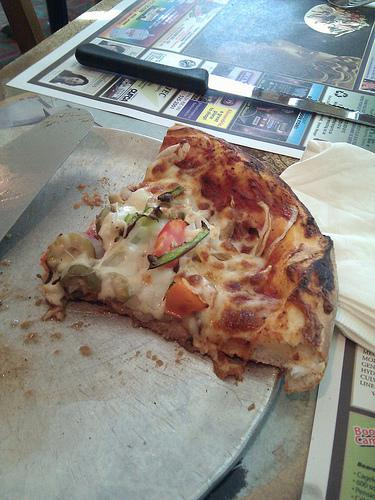Describe the table setting where the pizza is being served. The table setting includes a placemat full of ads, a newspaper, white napkins, a black-handled knife, a metal pizza server, and a round silver pan holding the pizza. List three emotions you may associate with this image. Happiness, satisfaction, and craving. Count the number of visible utensils in the image and describe their functions. There are 3 utensils: a knife for cutting, a metal pizza server for serving, and a silver spatula for handling the pizza slice. Identify the primary object in the image and describe its appearance. A thick crust pizza topped with melted cheese and various toppings, served on a round metal pan. Can you see any print material in the image? If so, describe its location and appearance. There is a newspaper placemat on the table beneath the pizza, which is full of ads. What is the primary interaction between the objects in the image? The primary interaction is between the pizza, its toppings, and the utensils used to serve and cut it. How is the pizza presented in the image? The pizza is showcased on a round silver pan, with a metal pizza server and other utensils placed around it, and a newspaper placemat on the table. Are there any imperfections on the pizza? If so, describe them. There is a burnt spot on the pizza. What are some of the toppings present on the pizza? Green peppers, tomatoes, red onions, green olives, and mushrooms. Assess the overall quality of the image in terms of sharpness and details. The image is quite sharp and detailed, showing intricate aspects of the pizza and its surroundings clearly. Locate the slice of green pepper on the pizza. X:148, Y:220, Width:60, Height:60 What is the sentiment expressed by the image? Indulgence, hunger Identify objects interacting with each other. Pizza on the pan, cheese melted on pizza, toppings on pizza, knife and pizza server touching the pan, napkins near the pizza. Can you see a fork on the table? There is a knife and a pizza server mentioned in the image, but no fork. Identify the type of knife shown in the image. Knife with black handle Determine the material the pan is made of. Metal Describe the scene shown in the image. A pizza on a silver pan loaded with cheese and toppings like green peppers, red onions, olives, tomato slices, and mushrooms, with a thick crust and a burn spot. A metal server, black-handled knife, white napkins, and newspaper present on the table. The plate is on a placemat with ads. What are some objects found in the image? Pizza, pan, green peppers, tomatoes, knife, newspaper, napkins, pizza server, red onions, olives, mushrooms, placemat. Can you find a pizza with thin crust and no cheese? The pizza in the image has a thick crust and melted cheese on top. What color are the olives on the pizza? Green Are there any purple olives on the pizza? The olives on the pizza in the image are green, not purple. What are the properties of the knife in the image? The knife has a black handle, and it is on the table. Identify the pizza size and crust type as described in the image. Thick crust, large slice, width: 299, height: 299. Locate the burnt spot on the pizza. X:291, Y:253, Width:42, Height:42 Where is the orange handle on the knife? The knife in the image has a black handle, not an orange one. Which objects are on the pizza? Green peppers, red onions, green olives, tomato slices, mushrooms, and melted cheese. Describe the emotions conveyed by the image. Hungry, satisfied, indulgence, craving. Is there a blue pan with pizza on it? The pan in the image is made of metal and there is no mention of it being blue. Describe the state of the pizza. Cooked, width: 156, height: 156 What are some objects on the table besides the pizza? Knife, newspaper, pizza server, napkins, placemat. Determine the type of media present on the table. Newspaper, width: 233, height: 233 List the ingredients found on the pizza Green peppers, red onions, green olives, tomato slices, mushrooms, and cheese. Is there a slice of green tomato on the pizza? The tomato on the pizza is red, not green. Identify the structure of the placement in the image. Placemat full of ads, width: 369, height: 369 